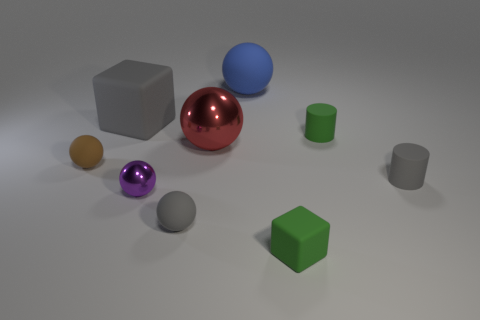Can you describe the position and color of the largest cube in the image? Certainly! The largest cube in the image is of a light grey color. It's positioned on the left side of the picture, slightly towards the center from the image perspective, and it's resting on one of its faces on the surface. 